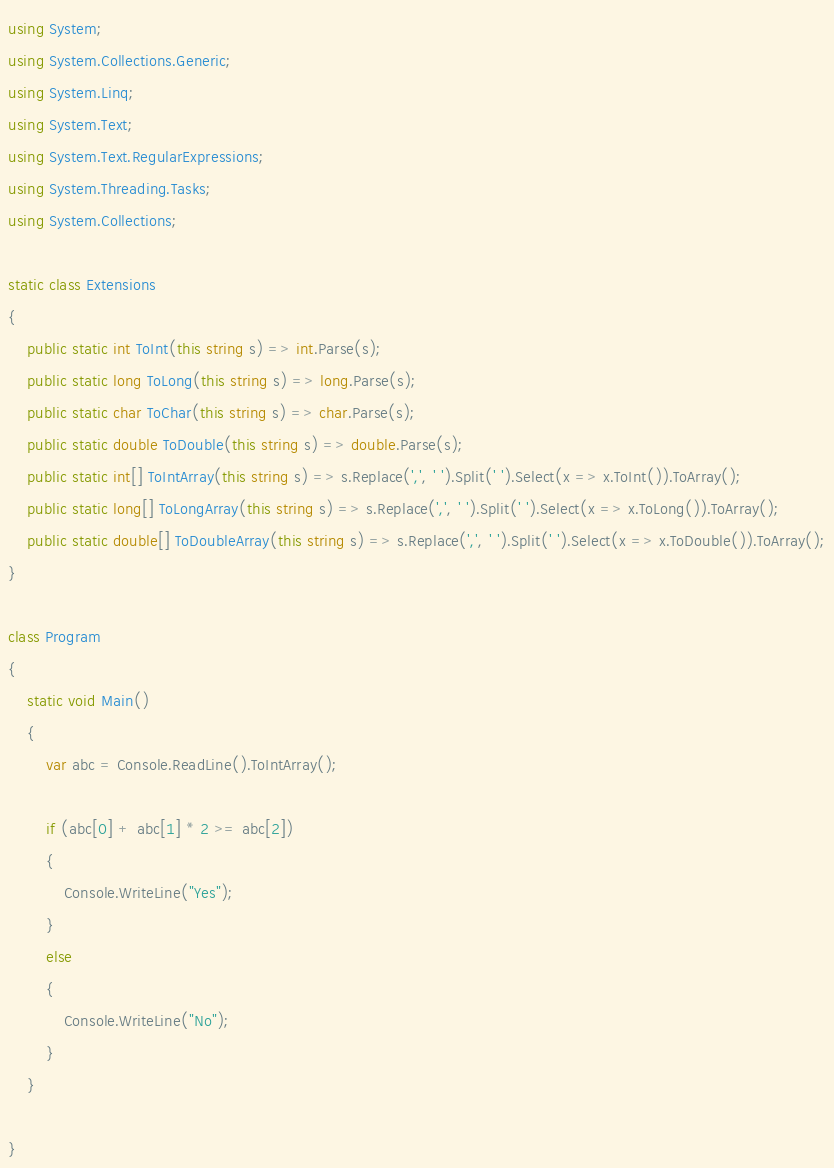<code> <loc_0><loc_0><loc_500><loc_500><_C#_>using System;
using System.Collections.Generic;
using System.Linq;
using System.Text;
using System.Text.RegularExpressions;
using System.Threading.Tasks;
using System.Collections;

static class Extensions
{
    public static int ToInt(this string s) => int.Parse(s);
    public static long ToLong(this string s) => long.Parse(s);
    public static char ToChar(this string s) => char.Parse(s);
    public static double ToDouble(this string s) => double.Parse(s);
    public static int[] ToIntArray(this string s) => s.Replace(',', ' ').Split(' ').Select(x => x.ToInt()).ToArray();
    public static long[] ToLongArray(this string s) => s.Replace(',', ' ').Split(' ').Select(x => x.ToLong()).ToArray();
    public static double[] ToDoubleArray(this string s) => s.Replace(',', ' ').Split(' ').Select(x => x.ToDouble()).ToArray();
}

class Program
{
    static void Main()
    {
        var abc = Console.ReadLine().ToIntArray();

        if (abc[0] + abc[1] * 2 >= abc[2])
        {
            Console.WriteLine("Yes");
        }
        else
        {
            Console.WriteLine("No");
        }
    }
    
}</code> 